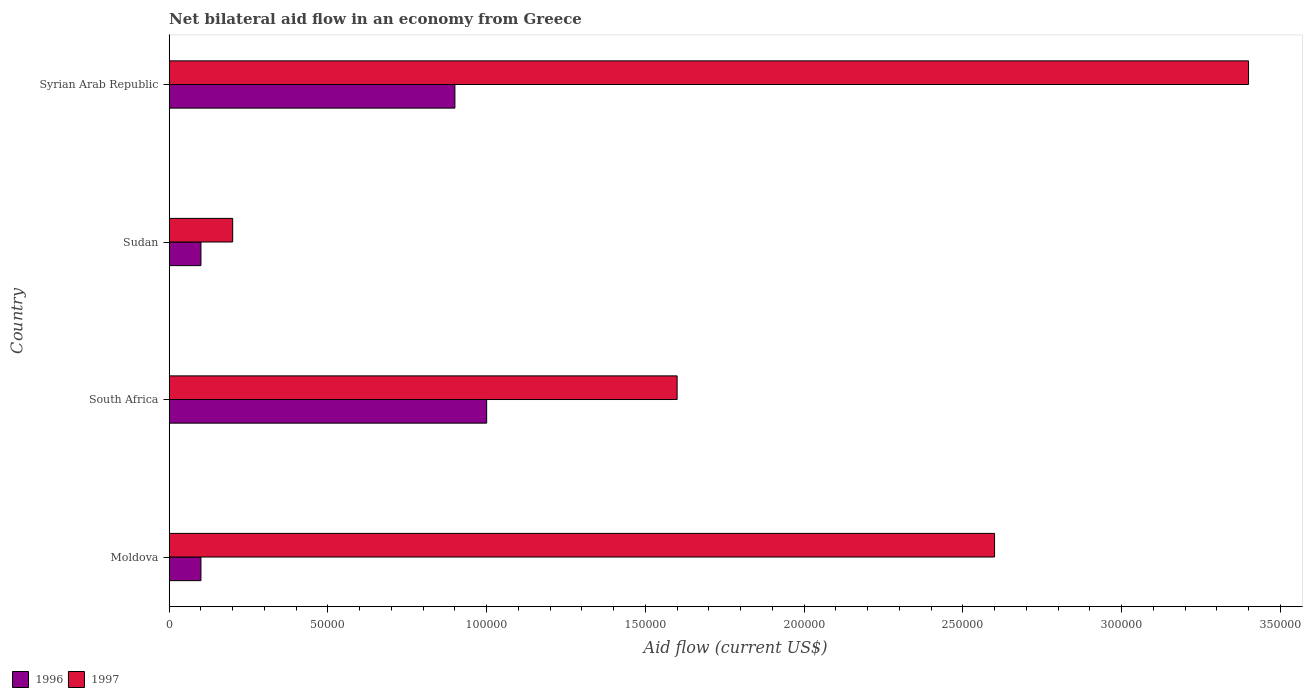How many different coloured bars are there?
Provide a succinct answer. 2. How many groups of bars are there?
Offer a very short reply. 4. How many bars are there on the 2nd tick from the bottom?
Keep it short and to the point. 2. What is the label of the 2nd group of bars from the top?
Keep it short and to the point. Sudan. What is the net bilateral aid flow in 1996 in Syrian Arab Republic?
Make the answer very short. 9.00e+04. Across all countries, what is the maximum net bilateral aid flow in 1996?
Your answer should be very brief. 1.00e+05. In which country was the net bilateral aid flow in 1996 maximum?
Offer a very short reply. South Africa. In which country was the net bilateral aid flow in 1997 minimum?
Offer a very short reply. Sudan. What is the total net bilateral aid flow in 1996 in the graph?
Keep it short and to the point. 2.10e+05. What is the difference between the net bilateral aid flow in 1997 in South Africa and that in Sudan?
Your response must be concise. 1.40e+05. What is the average net bilateral aid flow in 1997 per country?
Provide a succinct answer. 1.95e+05. What is the difference between the net bilateral aid flow in 1997 and net bilateral aid flow in 1996 in Syrian Arab Republic?
Provide a succinct answer. 2.50e+05. In how many countries, is the net bilateral aid flow in 1996 greater than 30000 US$?
Give a very brief answer. 2. Is the net bilateral aid flow in 1996 in Moldova less than that in Sudan?
Provide a short and direct response. No. Is the difference between the net bilateral aid flow in 1997 in South Africa and Syrian Arab Republic greater than the difference between the net bilateral aid flow in 1996 in South Africa and Syrian Arab Republic?
Keep it short and to the point. No. What is the difference between the highest and the second highest net bilateral aid flow in 1996?
Give a very brief answer. 10000. What is the difference between the highest and the lowest net bilateral aid flow in 1997?
Offer a very short reply. 3.20e+05. In how many countries, is the net bilateral aid flow in 1997 greater than the average net bilateral aid flow in 1997 taken over all countries?
Offer a terse response. 2. Is the sum of the net bilateral aid flow in 1997 in Moldova and Syrian Arab Republic greater than the maximum net bilateral aid flow in 1996 across all countries?
Give a very brief answer. Yes. What does the 2nd bar from the top in Syrian Arab Republic represents?
Your answer should be compact. 1996. How many bars are there?
Ensure brevity in your answer.  8. Are all the bars in the graph horizontal?
Provide a short and direct response. Yes. What is the difference between two consecutive major ticks on the X-axis?
Provide a short and direct response. 5.00e+04. Are the values on the major ticks of X-axis written in scientific E-notation?
Make the answer very short. No. Does the graph contain any zero values?
Make the answer very short. No. Does the graph contain grids?
Provide a succinct answer. No. How are the legend labels stacked?
Give a very brief answer. Horizontal. What is the title of the graph?
Make the answer very short. Net bilateral aid flow in an economy from Greece. Does "1973" appear as one of the legend labels in the graph?
Ensure brevity in your answer.  No. What is the label or title of the X-axis?
Ensure brevity in your answer.  Aid flow (current US$). What is the Aid flow (current US$) in 1996 in Moldova?
Keep it short and to the point. 10000. What is the Aid flow (current US$) in 1997 in South Africa?
Offer a very short reply. 1.60e+05. What is the Aid flow (current US$) in 1996 in Sudan?
Ensure brevity in your answer.  10000. What is the Aid flow (current US$) in 1997 in Sudan?
Ensure brevity in your answer.  2.00e+04. What is the Aid flow (current US$) of 1996 in Syrian Arab Republic?
Offer a terse response. 9.00e+04. Across all countries, what is the maximum Aid flow (current US$) in 1996?
Your answer should be very brief. 1.00e+05. Across all countries, what is the minimum Aid flow (current US$) in 1997?
Your answer should be compact. 2.00e+04. What is the total Aid flow (current US$) in 1996 in the graph?
Offer a very short reply. 2.10e+05. What is the total Aid flow (current US$) in 1997 in the graph?
Provide a short and direct response. 7.80e+05. What is the difference between the Aid flow (current US$) of 1996 in Moldova and that in South Africa?
Ensure brevity in your answer.  -9.00e+04. What is the difference between the Aid flow (current US$) in 1997 in Moldova and that in Sudan?
Your answer should be compact. 2.40e+05. What is the difference between the Aid flow (current US$) in 1996 in Moldova and that in Syrian Arab Republic?
Provide a succinct answer. -8.00e+04. What is the difference between the Aid flow (current US$) of 1997 in Moldova and that in Syrian Arab Republic?
Provide a succinct answer. -8.00e+04. What is the difference between the Aid flow (current US$) in 1996 in South Africa and that in Sudan?
Provide a short and direct response. 9.00e+04. What is the difference between the Aid flow (current US$) of 1997 in South Africa and that in Sudan?
Make the answer very short. 1.40e+05. What is the difference between the Aid flow (current US$) of 1997 in South Africa and that in Syrian Arab Republic?
Provide a succinct answer. -1.80e+05. What is the difference between the Aid flow (current US$) in 1997 in Sudan and that in Syrian Arab Republic?
Your response must be concise. -3.20e+05. What is the difference between the Aid flow (current US$) in 1996 in Moldova and the Aid flow (current US$) in 1997 in South Africa?
Your response must be concise. -1.50e+05. What is the difference between the Aid flow (current US$) of 1996 in Moldova and the Aid flow (current US$) of 1997 in Syrian Arab Republic?
Provide a succinct answer. -3.30e+05. What is the difference between the Aid flow (current US$) in 1996 in South Africa and the Aid flow (current US$) in 1997 in Syrian Arab Republic?
Offer a very short reply. -2.40e+05. What is the difference between the Aid flow (current US$) of 1996 in Sudan and the Aid flow (current US$) of 1997 in Syrian Arab Republic?
Your answer should be compact. -3.30e+05. What is the average Aid flow (current US$) of 1996 per country?
Offer a terse response. 5.25e+04. What is the average Aid flow (current US$) of 1997 per country?
Your response must be concise. 1.95e+05. What is the difference between the Aid flow (current US$) in 1996 and Aid flow (current US$) in 1997 in South Africa?
Give a very brief answer. -6.00e+04. What is the difference between the Aid flow (current US$) of 1996 and Aid flow (current US$) of 1997 in Syrian Arab Republic?
Provide a short and direct response. -2.50e+05. What is the ratio of the Aid flow (current US$) in 1996 in Moldova to that in South Africa?
Make the answer very short. 0.1. What is the ratio of the Aid flow (current US$) of 1997 in Moldova to that in South Africa?
Your answer should be very brief. 1.62. What is the ratio of the Aid flow (current US$) in 1996 in Moldova to that in Sudan?
Give a very brief answer. 1. What is the ratio of the Aid flow (current US$) of 1997 in Moldova to that in Sudan?
Make the answer very short. 13. What is the ratio of the Aid flow (current US$) of 1996 in Moldova to that in Syrian Arab Republic?
Your answer should be compact. 0.11. What is the ratio of the Aid flow (current US$) in 1997 in Moldova to that in Syrian Arab Republic?
Ensure brevity in your answer.  0.76. What is the ratio of the Aid flow (current US$) of 1997 in South Africa to that in Sudan?
Your answer should be compact. 8. What is the ratio of the Aid flow (current US$) in 1996 in South Africa to that in Syrian Arab Republic?
Keep it short and to the point. 1.11. What is the ratio of the Aid flow (current US$) of 1997 in South Africa to that in Syrian Arab Republic?
Your answer should be very brief. 0.47. What is the ratio of the Aid flow (current US$) of 1997 in Sudan to that in Syrian Arab Republic?
Your response must be concise. 0.06. What is the difference between the highest and the second highest Aid flow (current US$) of 1997?
Your answer should be compact. 8.00e+04. What is the difference between the highest and the lowest Aid flow (current US$) in 1997?
Ensure brevity in your answer.  3.20e+05. 